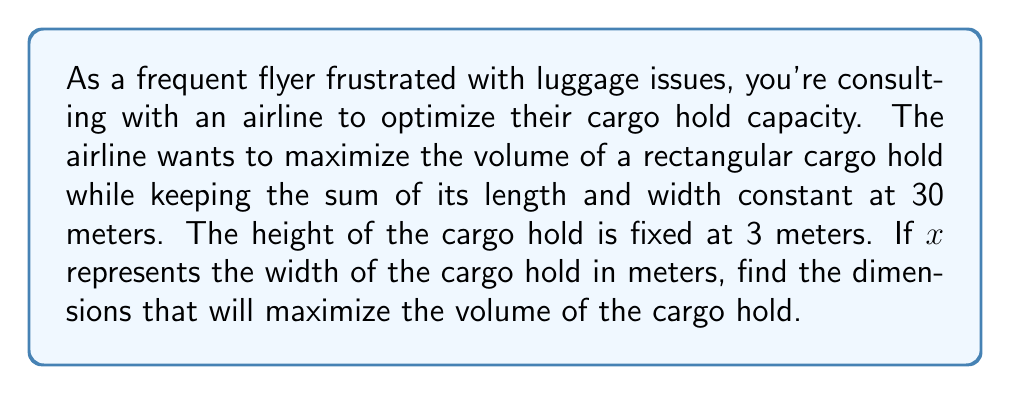Solve this math problem. Let's approach this step-by-step:

1) Let $x$ be the width of the cargo hold in meters.
   Let $y$ be the length of the cargo hold in meters.

2) We're given that the sum of length and width is constant at 30 meters:
   $x + y = 30$
   Therefore, $y = 30 - x$

3) The height is fixed at 3 meters.

4) The volume $V$ of the cargo hold is given by:
   $V = x \cdot y \cdot 3$
   $V = x(30-x) \cdot 3$
   $V = 90x - 3x^2$

5) To maximize the volume, we need to find the vertex of this quadratic function.

6) The general form of a quadratic function is:
   $f(x) = ax^2 + bx + c$
   In our case, $a = -3$, $b = 90$, and $c = 0$

7) The x-coordinate of the vertex is given by $-\frac{b}{2a}$:
   $x = -\frac{90}{2(-3)} = \frac{90}{6} = 15$

8) This means the width should be 15 meters.

9) The length would then be:
   $y = 30 - x = 30 - 15 = 15$ meters

10) We can verify this is a maximum by checking the second derivative:
    $\frac{d^2V}{dx^2} = -6$, which is negative, confirming a maximum.

Therefore, the cargo hold should be 15 meters wide and 15 meters long to maximize its volume.
Answer: The optimal dimensions are: width = 15 meters, length = 15 meters, height = 3 meters. 